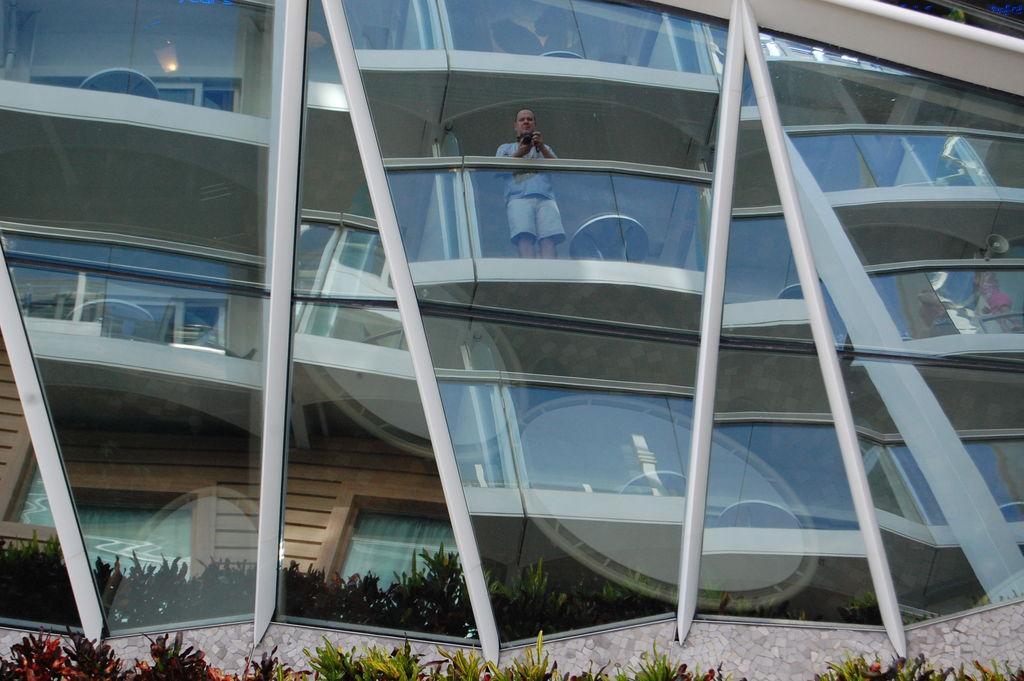Describe this image in one or two sentences. In the image we can see a building made up of glass. We can even see a man standing and wearing clothes. Here we can see the plants and the light. 